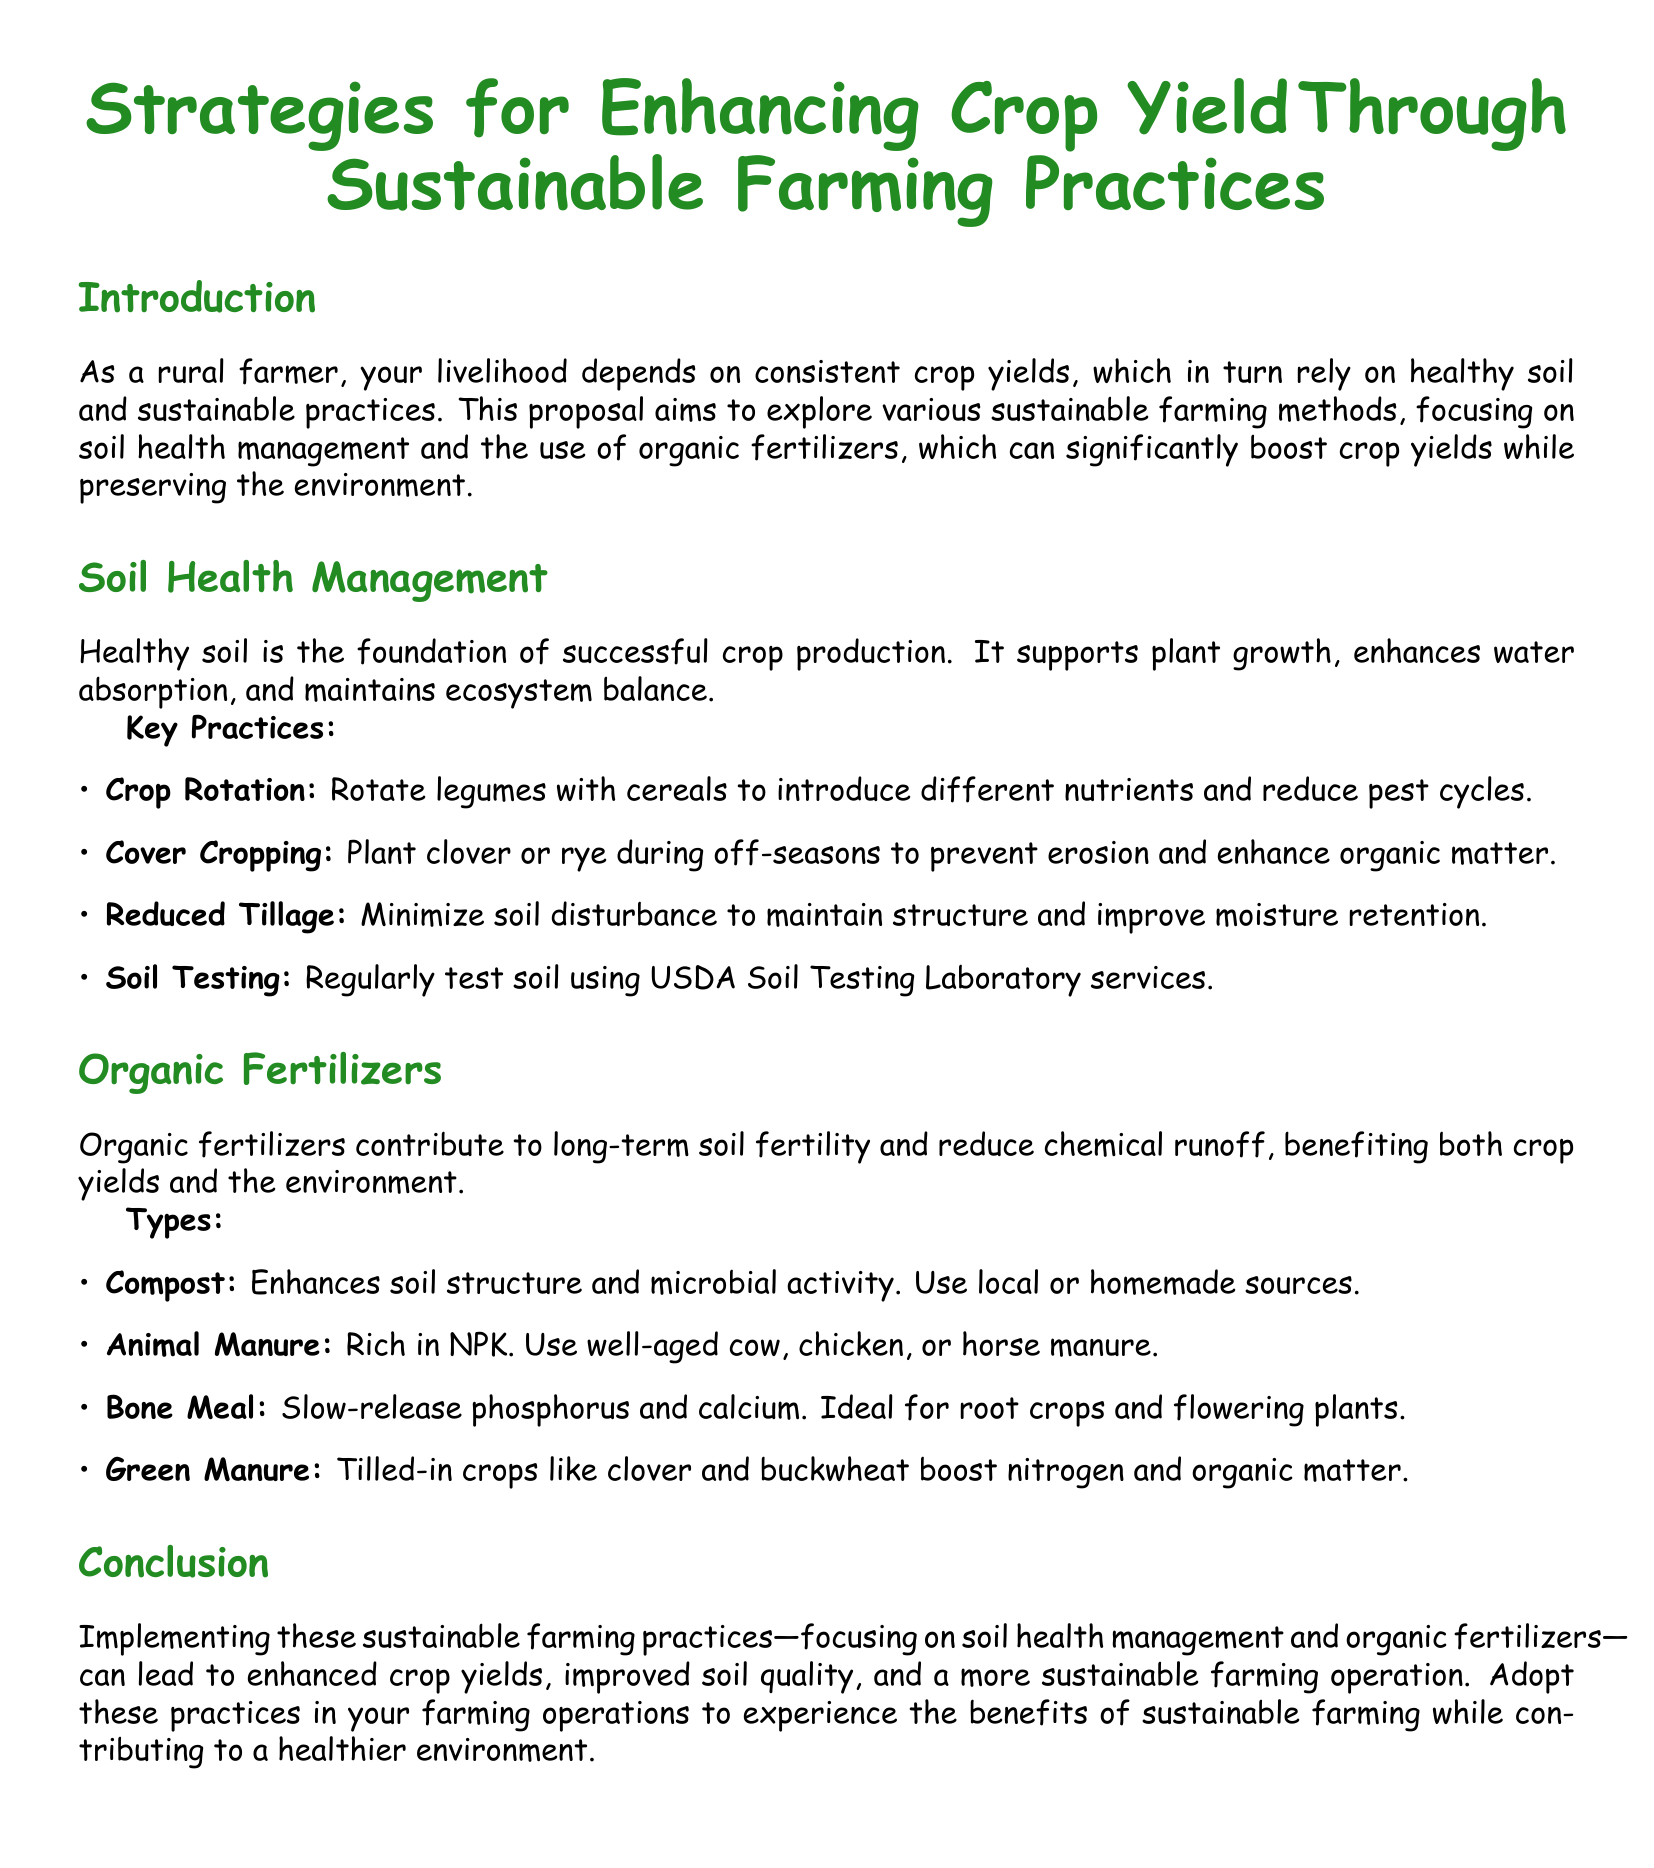What are the key practices for soil health management? The document lists key practices for soil health management including crop rotation, cover cropping, reduced tillage, and soil testing.
Answer: Crop rotation, cover cropping, reduced tillage, soil testing What is the purpose of using organic fertilizers? The document states that organic fertilizers contribute to long-term soil fertility and reduce chemical runoff.
Answer: Long-term soil fertility and reduce chemical runoff What type of manure is mentioned as rich in NPK? The proposal specifically mentions well-aged cow, chicken, or horse manure as sources of rich NPK.
Answer: Cow, chicken, or horse manure How can cover cropping benefit soil? Cover cropping is mentioned as a practice that prevents erosion and enhances organic matter in the soil.
Answer: Prevent erosion and enhance organic matter What is one type of organic fertilizer that is ideal for root crops? The document indicates that bone meal is ideal for root crops and flowering plants.
Answer: Bone Meal How does reduced tillage affect soil? The document mentions that reduced tillage minimizes soil disturbance, maintaining structure and improving moisture retention.
Answer: Maintains structure and improves moisture retention What are the benefits of implementing sustainable farming practices? The conclusion states that implementing these practices can enhance crop yields and improve soil quality while contributing to a healthier environment.
Answer: Enhanced crop yields, improved soil quality, healthier environment What is one of the consequences of not practicing soil health management? The document implies that neglecting soil health management could lead to decreased crop yields as healthy soil is the foundation of successful crop production.
Answer: Decreased crop yields What type of crop should be used for green manure? The document mentions tilling in crops like clover and buckwheat for boosting nitrogen and organic matter.
Answer: Clover and buckwheat 